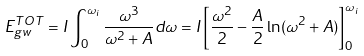<formula> <loc_0><loc_0><loc_500><loc_500>E ^ { T O T } _ { g w } = I \int _ { 0 } ^ { \omega _ { i } } \frac { \omega ^ { 3 } } { \omega ^ { 2 } + A } d \omega = I \left [ \frac { \omega ^ { 2 } } { 2 } - \frac { A } { 2 } \ln ( \omega ^ { 2 } + A ) \right ] ^ { \omega _ { i } } _ { 0 }</formula> 